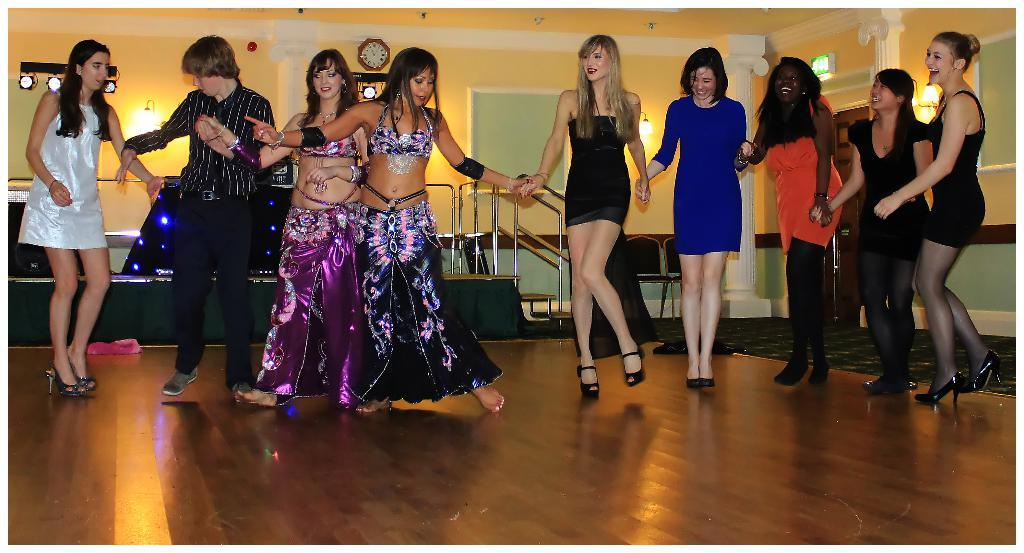What are the people in the image doing? There is a group of people dancing in the image. Where are the people dancing? The people are dancing on the floor. What can be seen in the background of the image? There are lights, stairs, and a wall visible in the background of the image. Is there any time-related object in the image? Yes, there is a clock attached to the wall. What type of border is present around the dancing area in the image? There is no border visible around the dancing area in the image. What amusement park ride can be seen in the background of the image? There is no amusement park ride present in the image; it features a group of people dancing on the floor with a background that includes lights, stairs, and a wall. 